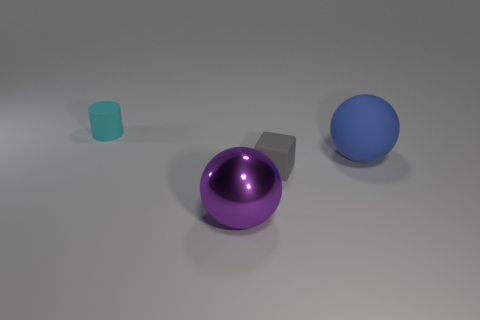Add 3 large brown metallic blocks. How many objects exist? 7 Subtract all blue balls. How many balls are left? 1 Subtract all blocks. How many objects are left? 3 Add 2 purple balls. How many purple balls are left? 3 Add 1 large brown rubber cylinders. How many large brown rubber cylinders exist? 1 Subtract 0 yellow balls. How many objects are left? 4 Subtract 1 cylinders. How many cylinders are left? 0 Subtract all yellow cylinders. Subtract all yellow spheres. How many cylinders are left? 1 Subtract all blocks. Subtract all big matte spheres. How many objects are left? 2 